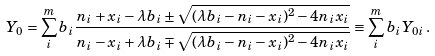<formula> <loc_0><loc_0><loc_500><loc_500>Y _ { 0 } = \sum _ { i } ^ { m } b _ { i } \frac { n _ { i } + x _ { i } - \lambda b _ { i } \pm \sqrt { ( \lambda b _ { i } - n _ { i } - x _ { i } ) ^ { 2 } - 4 n _ { i } x _ { i } } } { n _ { i } - x _ { i } + \lambda b _ { i } \mp \sqrt { ( \lambda b _ { i } - n _ { i } - x _ { i } ) ^ { 2 } - 4 n _ { i } x _ { i } } } \equiv \sum _ { i } ^ { m } b _ { i } Y _ { 0 i } \, .</formula> 